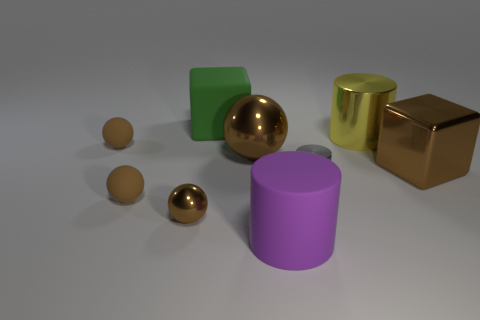Is the number of small brown metallic things less than the number of large brown metallic things?
Provide a short and direct response. Yes. How many big brown metal blocks are left of the yellow thing?
Your answer should be very brief. 0. What is the material of the big brown cube?
Make the answer very short. Metal. Do the large shiny cylinder and the large metal ball have the same color?
Give a very brief answer. No. Are there fewer big balls right of the gray object than yellow shiny objects?
Provide a short and direct response. Yes. There is a cylinder in front of the tiny brown shiny thing; what color is it?
Keep it short and to the point. Purple. What is the shape of the large yellow metal object?
Provide a short and direct response. Cylinder. There is a brown rubber ball that is in front of the large brown object in front of the big brown metallic ball; are there any matte balls behind it?
Keep it short and to the point. Yes. The tiny metallic thing on the left side of the large matte thing that is in front of the big brown shiny thing that is right of the big yellow metallic thing is what color?
Your answer should be compact. Brown. What is the material of the yellow object that is the same shape as the purple matte object?
Your answer should be compact. Metal. 